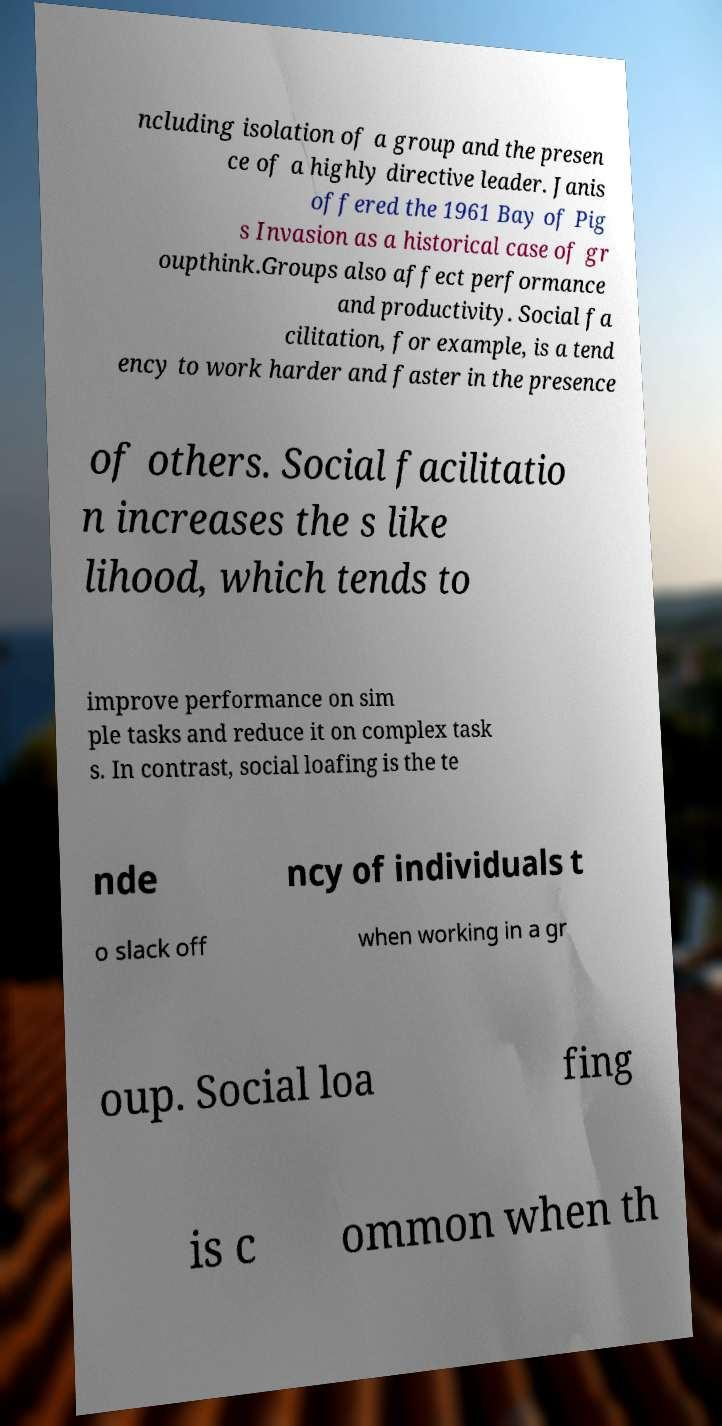I need the written content from this picture converted into text. Can you do that? ncluding isolation of a group and the presen ce of a highly directive leader. Janis offered the 1961 Bay of Pig s Invasion as a historical case of gr oupthink.Groups also affect performance and productivity. Social fa cilitation, for example, is a tend ency to work harder and faster in the presence of others. Social facilitatio n increases the s like lihood, which tends to improve performance on sim ple tasks and reduce it on complex task s. In contrast, social loafing is the te nde ncy of individuals t o slack off when working in a gr oup. Social loa fing is c ommon when th 